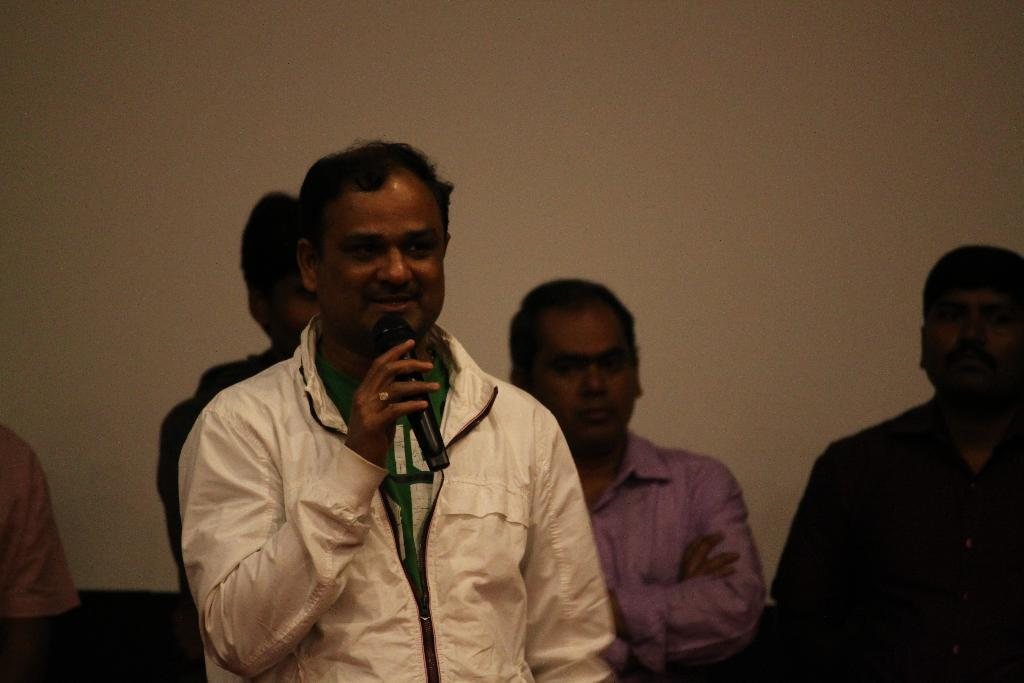What are the people in the image doing near the wall? There are people standing near a wall in the image. What object is near the wall in the image? There is an object near the wall in the image. Can you describe the man in the image? There is a man with a cream-colored jacket in the image, and he is holding a microphone. What is the man doing in the image? The man is talking in the image. How does the crowd react to the man's hope and reason in the image? There is no crowd present in the image, and the man's actions or thoughts are not explicitly mentioned, so it is impossible to determine how a crowd might react. 